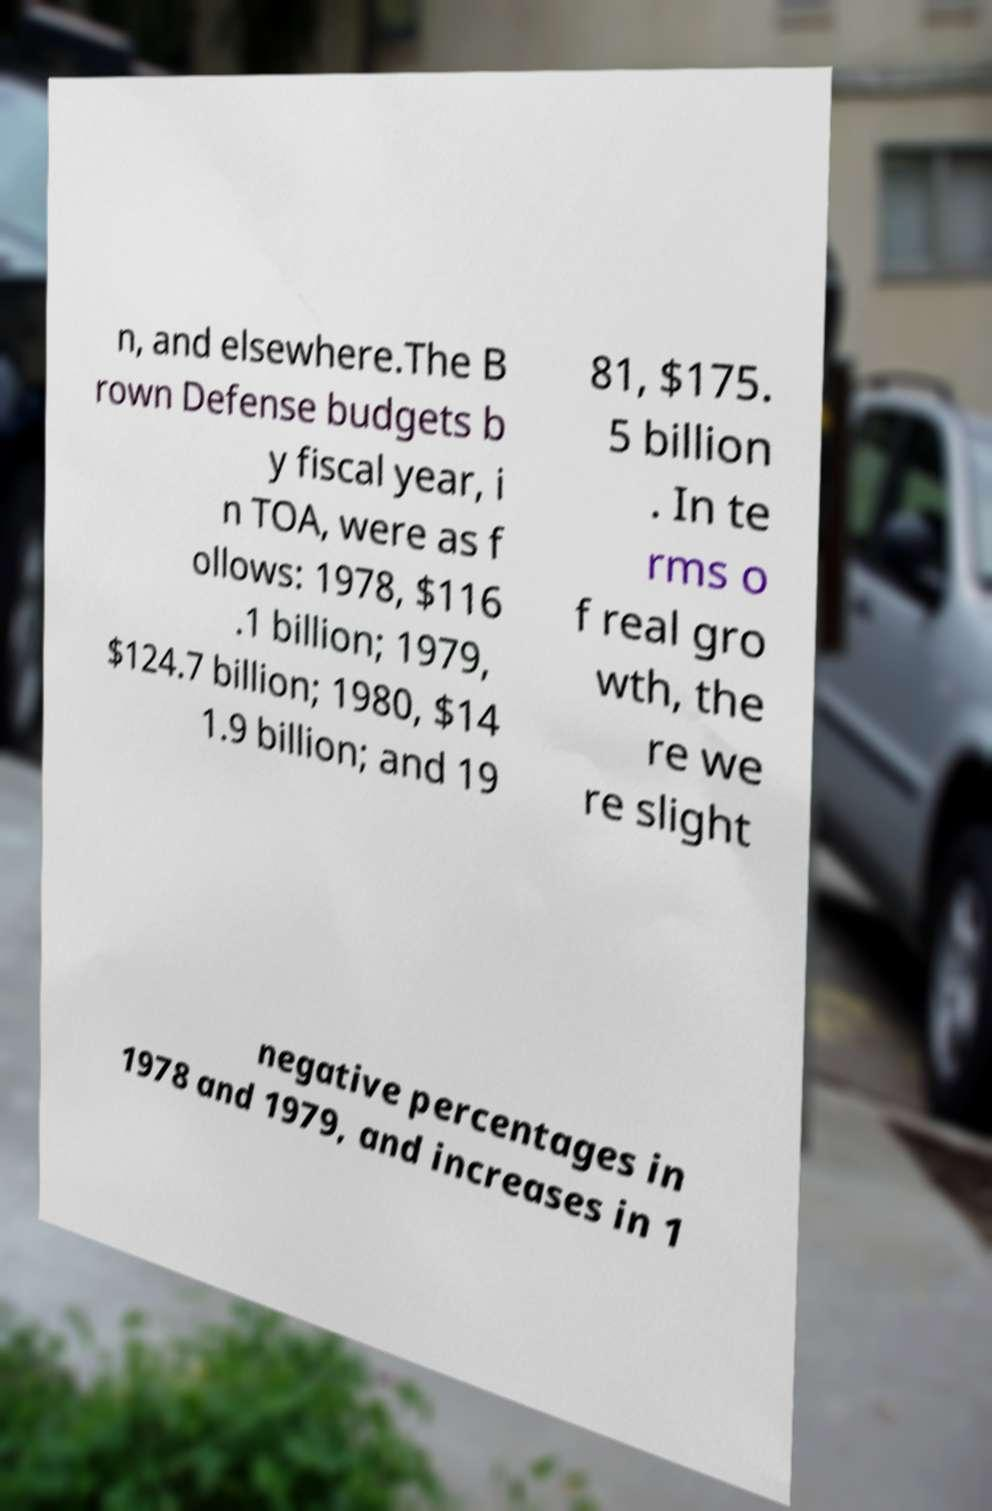Could you extract and type out the text from this image? n, and elsewhere.The B rown Defense budgets b y fiscal year, i n TOA, were as f ollows: 1978, $116 .1 billion; 1979, $124.7 billion; 1980, $14 1.9 billion; and 19 81, $175. 5 billion . In te rms o f real gro wth, the re we re slight negative percentages in 1978 and 1979, and increases in 1 